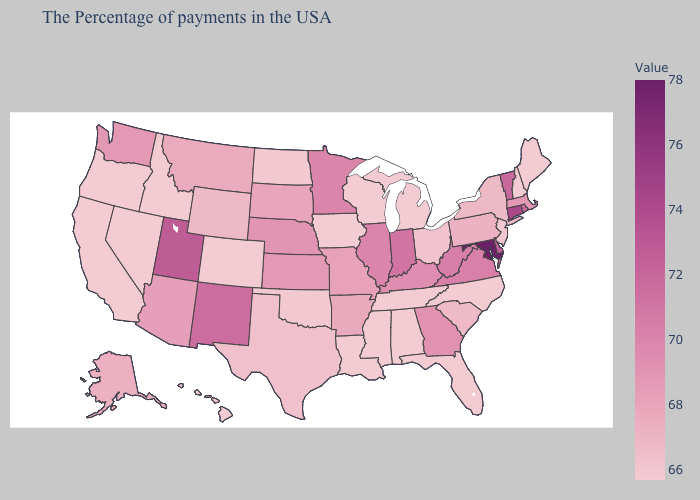Does Virginia have the highest value in the South?
Be succinct. No. Does Idaho have a lower value than Rhode Island?
Keep it brief. Yes. Among the states that border Idaho , does Oregon have the lowest value?
Answer briefly. Yes. Does the map have missing data?
Keep it brief. No. Which states hav the highest value in the Northeast?
Answer briefly. Connecticut. Does Massachusetts have the lowest value in the USA?
Write a very short answer. No. Among the states that border Mississippi , does Louisiana have the lowest value?
Write a very short answer. Yes. 